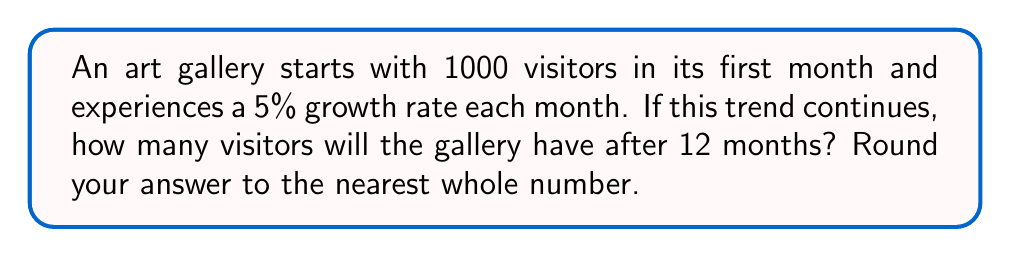Provide a solution to this math problem. To solve this problem, we'll use the exponential growth formula:

$$A = P(1 + r)^t$$

Where:
$A$ = Final amount
$P$ = Initial amount (1000 visitors)
$r$ = Growth rate (5% = 0.05)
$t$ = Time period (12 months)

Let's substitute these values into the formula:

$$A = 1000(1 + 0.05)^{12}$$

Now, let's calculate step-by-step:

1) First, calculate $(1 + 0.05)$:
   $1 + 0.05 = 1.05$

2) Now, we need to calculate $1.05^{12}$:
   $1.05^{12} \approx 1.7958$

3) Finally, multiply this by the initial amount:
   $1000 \times 1.7958 \approx 1795.8$

4) Rounding to the nearest whole number:
   $1795.8 \approx 1796$

Therefore, after 12 months, the gallery will have approximately 1796 visitors.
Answer: 1796 visitors 